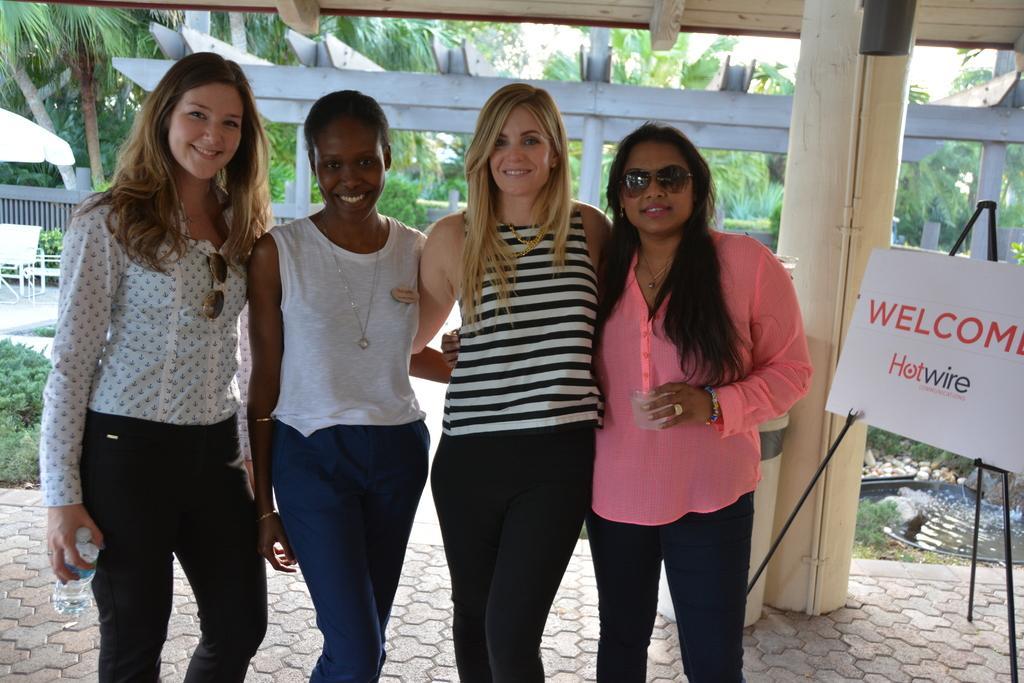Could you give a brief overview of what you see in this image? In this image we can see a group of people. There are many trees and plants in the image. There are few chairs and some objects at the left side of the image. There is a water at the right side of the image. There is a board at the right side of the image. 